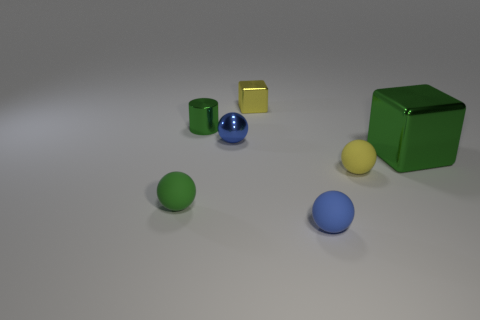What can you deduce about the textures of the different objects? The smoothness of the objects suggests they might have a polished or matte texture. The metallic cylinder and cube likely have a more reflective and smoother surface compared to the spheres and the larger cube, which might have a more diffuse reflectivity, attributing to how light is dispersed across their surfaces. 